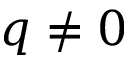<formula> <loc_0><loc_0><loc_500><loc_500>q \neq 0</formula> 